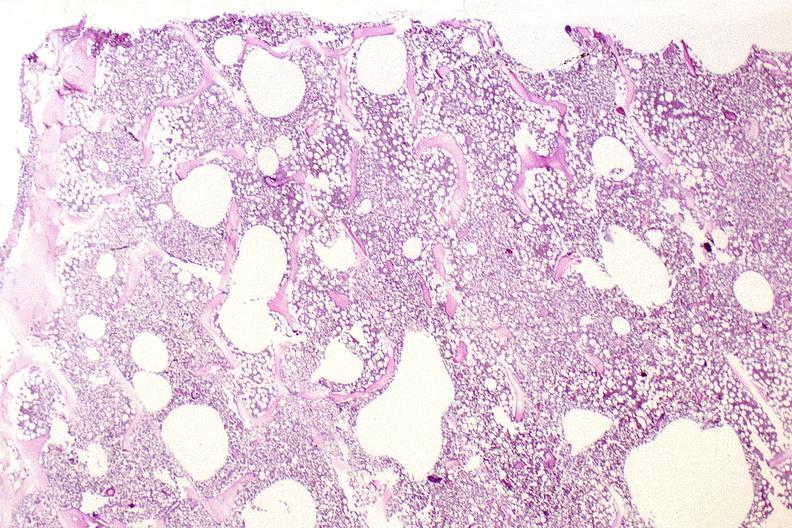does child show bone, vertebral body opsteopenia, osteoporosis?
Answer the question using a single word or phrase. No 